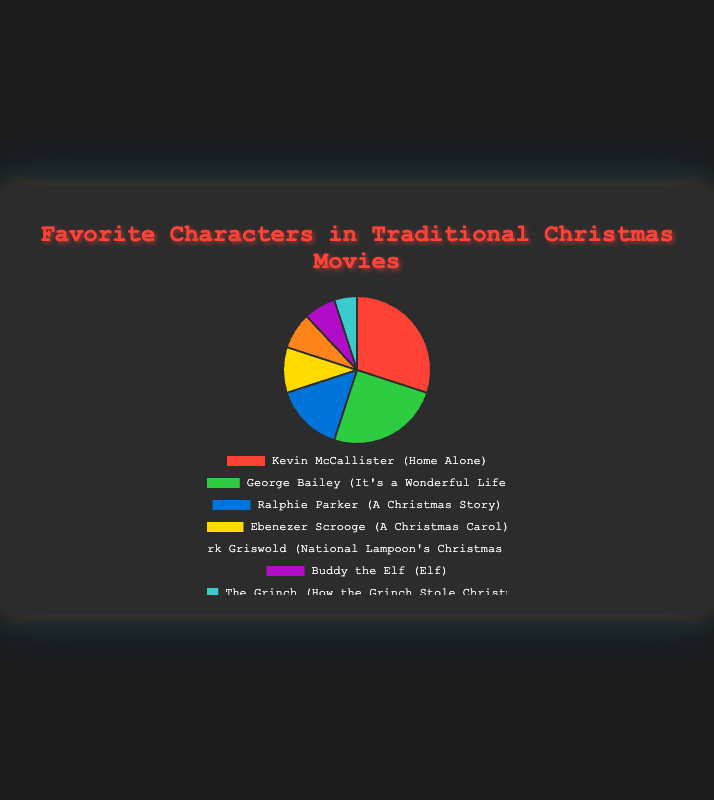Which character is the most favorite? The character with the highest percentage is the most favorite. Kevin McCallister received 30%, which is the highest.
Answer: Kevin McCallister Who is less favorite, The Grinch or Buddy the Elf? Compare the percentages for The Grinch (5%) and Buddy the Elf (7%). 5% is less than 7%.
Answer: The Grinch What is the combined percentage of George Bailey and Ralphie Parker? Add the percentages of George Bailey (25%) and Ralphie Parker (15%). 25% + 15% = 40%.
Answer: 40% How much more popular is Kevin McCallister compared to Ebenezer Scrooge? Subtract the percentage of Ebenezer Scrooge (10%) from Kevin McCallister (30%). 30% - 10% = 20%.
Answer: 20% Which character and movie are represented by the green color on the pie chart? Green color corresponds to George Bailey from "It's a Wonderful Life".
Answer: George Bailey (It's a Wonderful Life) What is the average popularity percentage of the characters from "Home Alone", "A Christmas Story", and "National Lampoon's Christmas Vacation"? Sum the percentages (30 + 15 + 8) and divide by 3. (30 + 15 + 8) / 3 = 17.67%.
Answer: 17.67% Arrange the characters in descending order of their popularity. List the characters' popularity percentages in descending order: Kevin McCallister (30%), George Bailey (25%), Ralphie Parker (15%), Ebenezer Scrooge (10%), Clark Griswold (8%), Buddy the Elf (7%), The Grinch (5%).
Answer: Kevin McCallister, George Bailey, Ralphie Parker, Ebenezer Scrooge, Clark Griswold, Buddy the Elf, The Grinch 